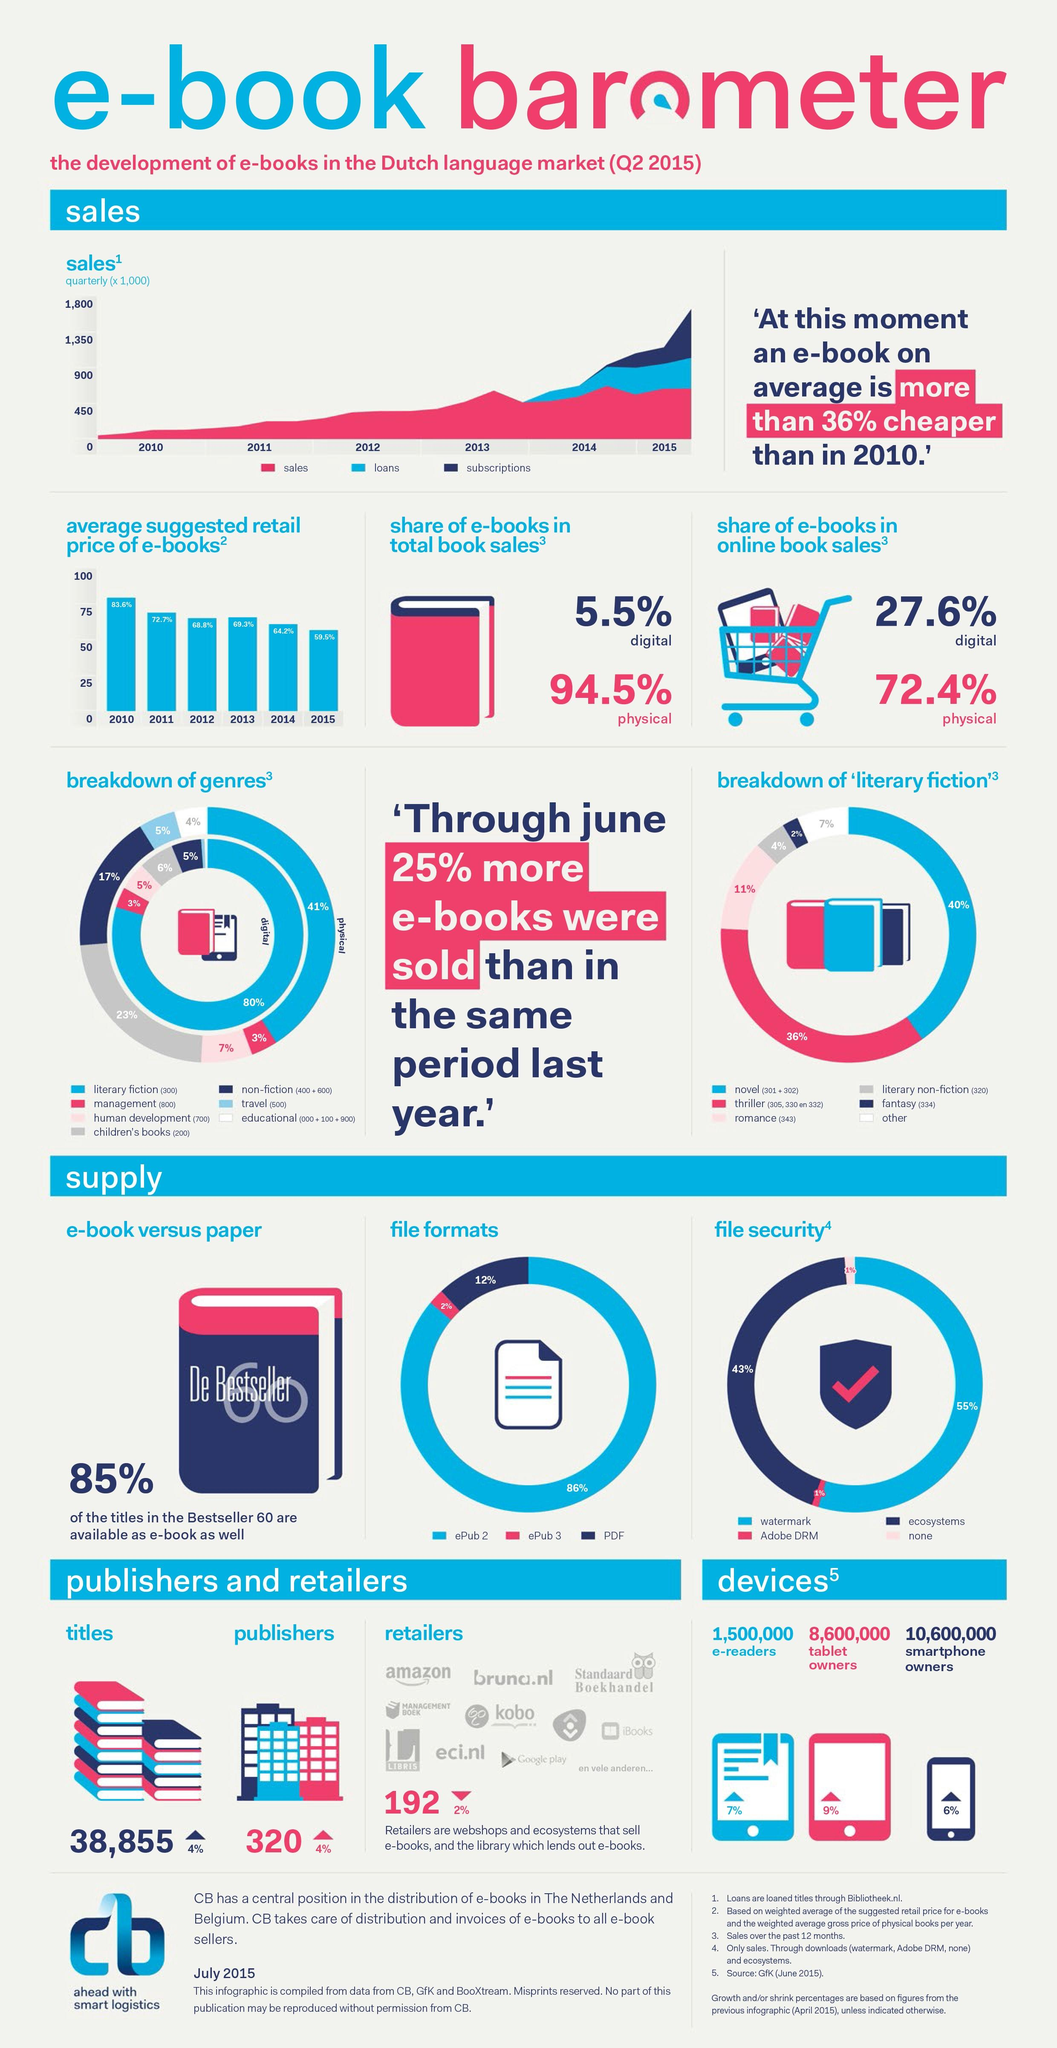Give some essential details in this illustration. Approximately 10.6 million people own smartphones in the United States. There are approximately 8,600,000 tablet owners in the country. 